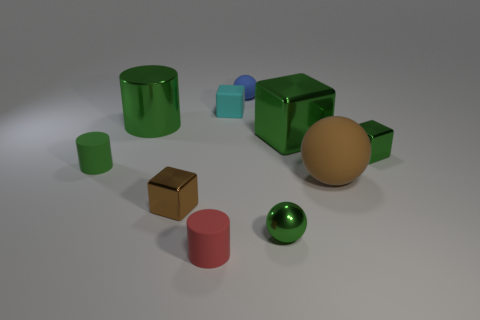The small green thing that is both on the right side of the large shiny cylinder and behind the big brown sphere is made of what material?
Provide a short and direct response. Metal. There is a brown metallic thing; is it the same size as the green object left of the shiny cylinder?
Make the answer very short. Yes. Are any large purple blocks visible?
Ensure brevity in your answer.  No. What material is the other big object that is the same shape as the red thing?
Ensure brevity in your answer.  Metal. What is the size of the green metallic object on the left side of the matte cylinder that is in front of the big brown object in front of the cyan matte object?
Provide a succinct answer. Large. There is a small brown cube; are there any small rubber objects to the left of it?
Your response must be concise. Yes. There is a cylinder that is the same material as the large green cube; what size is it?
Provide a succinct answer. Large. How many green metallic objects are the same shape as the brown rubber object?
Your response must be concise. 1. Is the material of the tiny cyan block the same as the sphere that is behind the large ball?
Ensure brevity in your answer.  Yes. Are there more objects in front of the green shiny cylinder than big cubes?
Your response must be concise. Yes. 